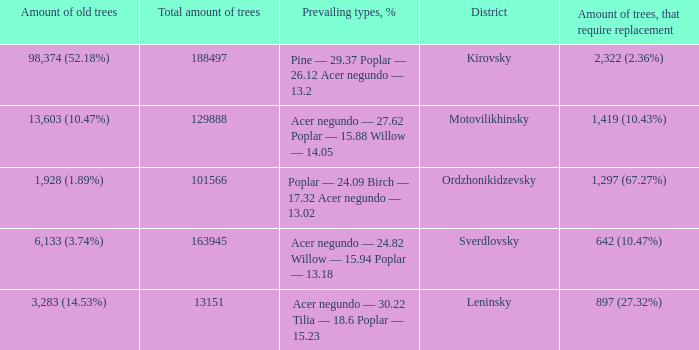What is the amount of trees, that require replacement when prevailing types, % is pine — 29.37 poplar — 26.12 acer negundo — 13.2? 2,322 (2.36%). 